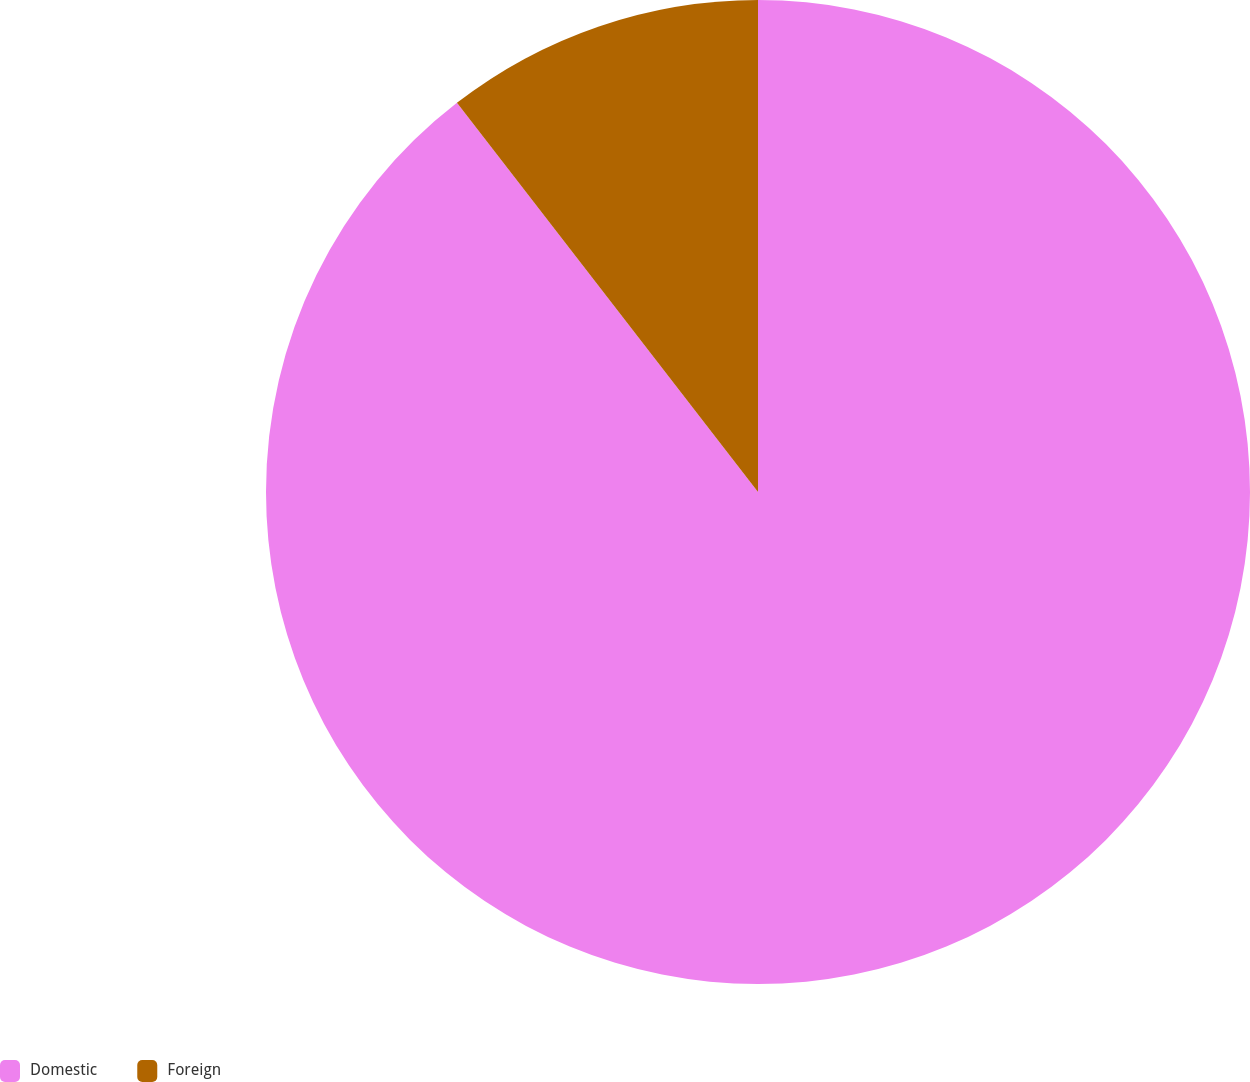Convert chart. <chart><loc_0><loc_0><loc_500><loc_500><pie_chart><fcel>Domestic<fcel>Foreign<nl><fcel>89.52%<fcel>10.48%<nl></chart> 